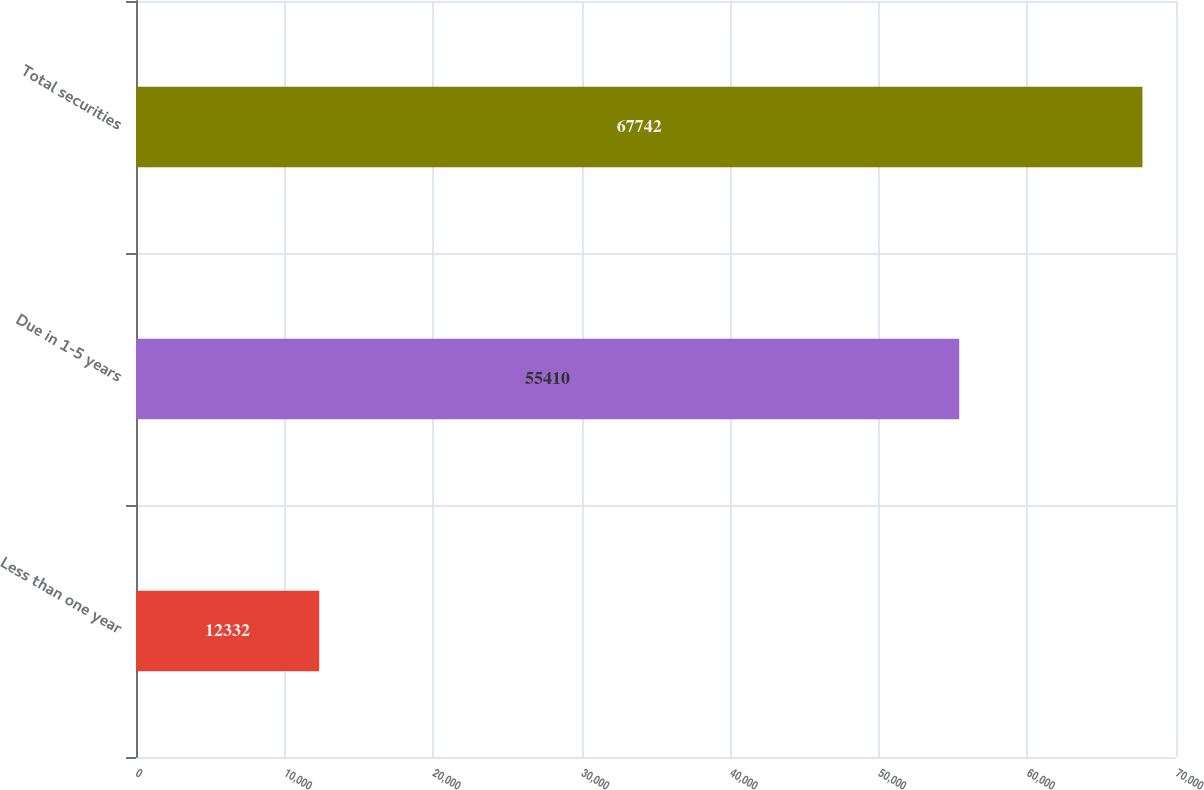Convert chart to OTSL. <chart><loc_0><loc_0><loc_500><loc_500><bar_chart><fcel>Less than one year<fcel>Due in 1-5 years<fcel>Total securities<nl><fcel>12332<fcel>55410<fcel>67742<nl></chart> 